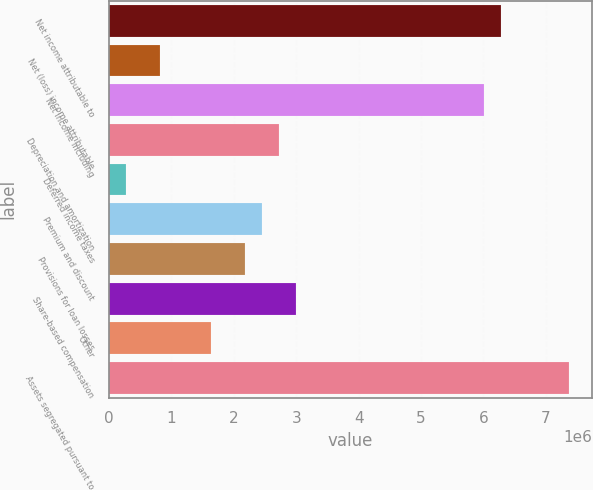<chart> <loc_0><loc_0><loc_500><loc_500><bar_chart><fcel>Net income attributable to<fcel>Net (loss) income attributable<fcel>Net income including<fcel>Depreciation and amortization<fcel>Deferred income taxes<fcel>Premium and discount<fcel>Provisions for loan losses<fcel>Share-based compensation<fcel>Other<fcel>Assets segregated pursuant to<nl><fcel>6.28075e+06<fcel>819924<fcel>6.00771e+06<fcel>2.73122e+06<fcel>273842<fcel>2.45817e+06<fcel>2.18513e+06<fcel>3.00426e+06<fcel>1.63905e+06<fcel>7.37292e+06<nl></chart> 